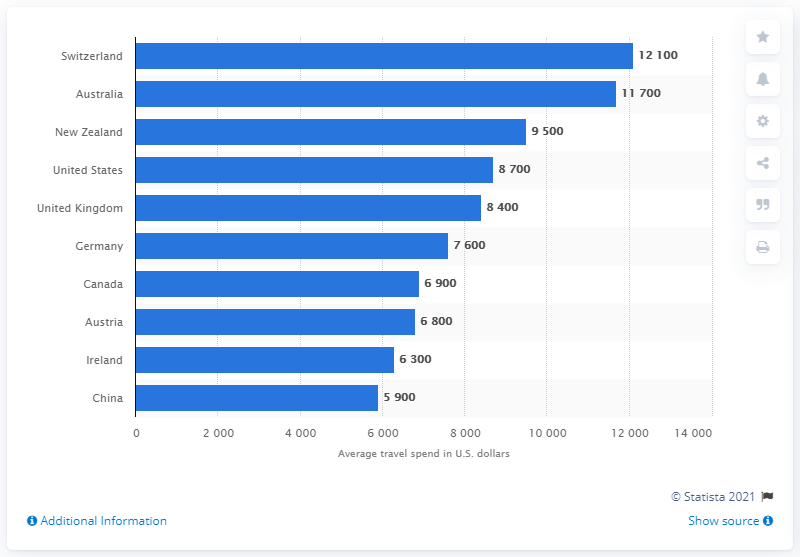Identify some key points in this picture. It is expected that Switzerland will be the country that spends the most on travel in 2015. 